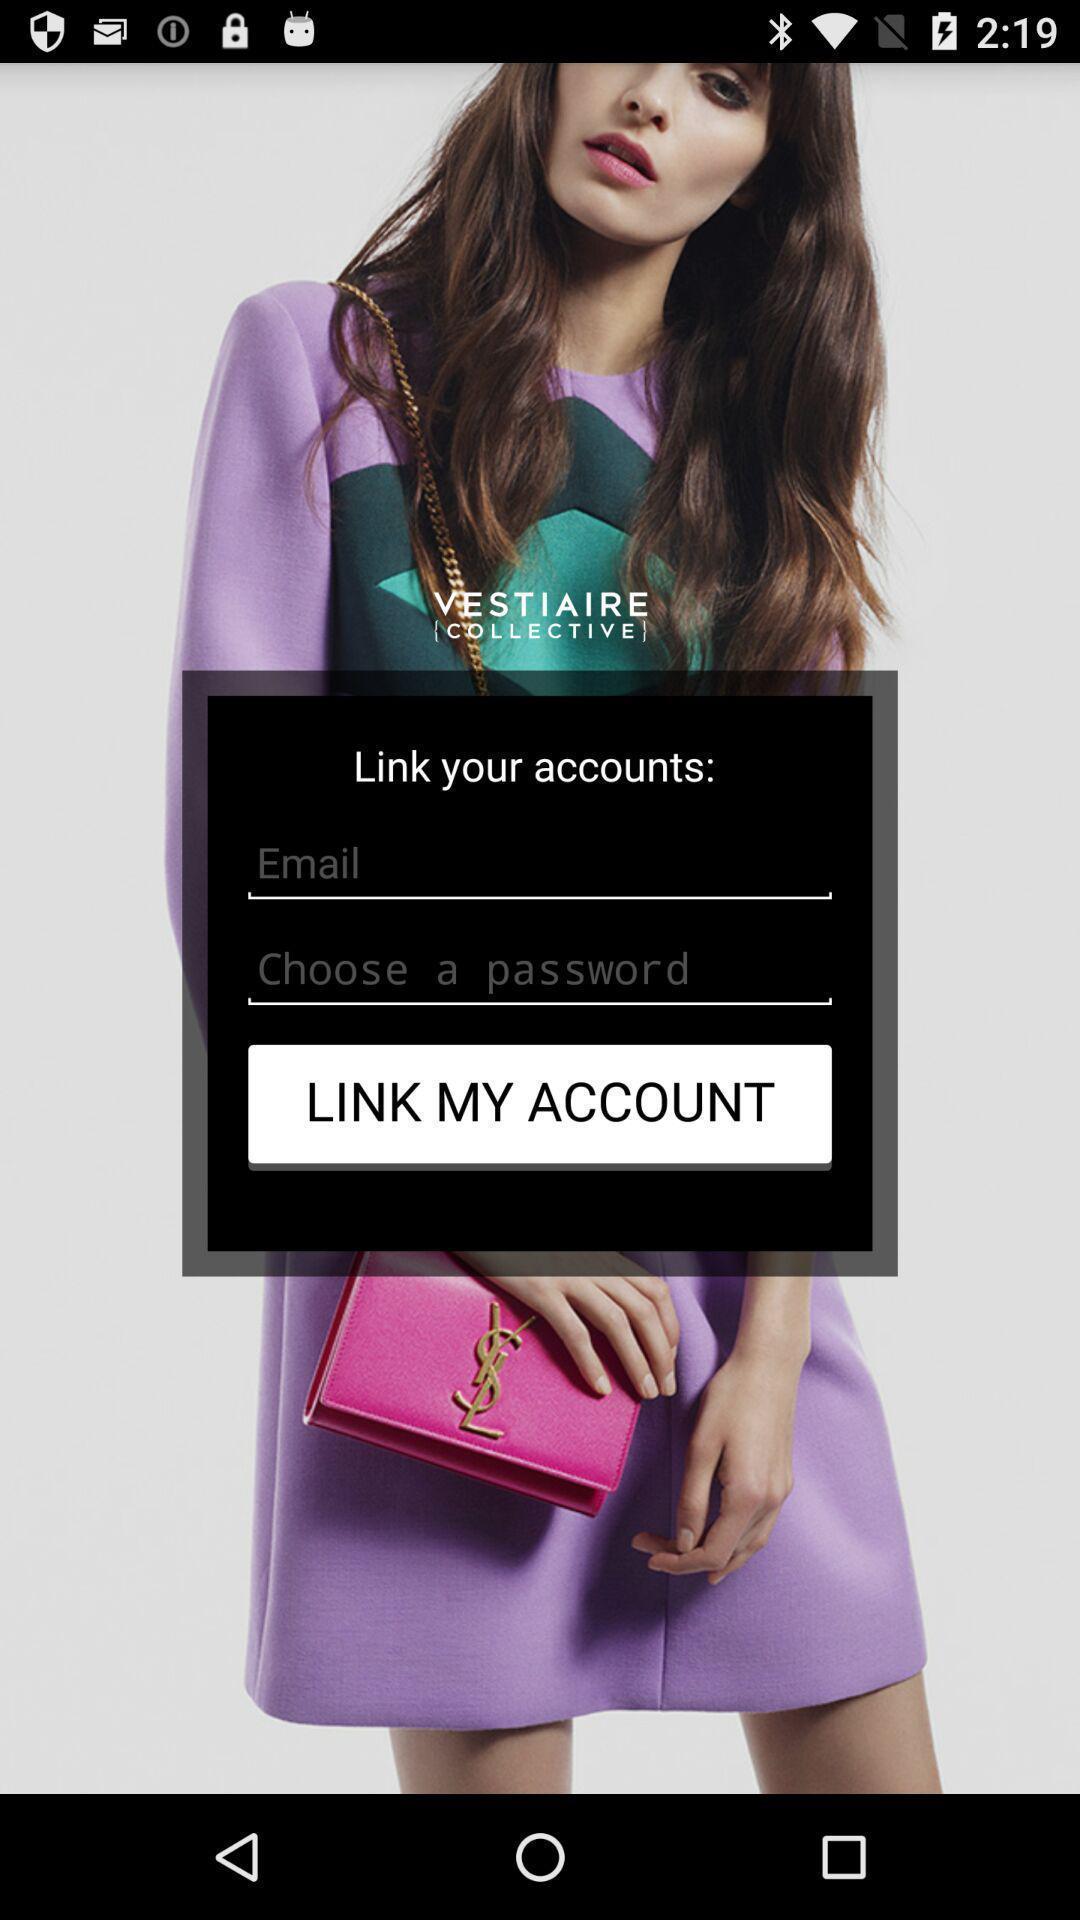Tell me what you see in this picture. Welcome screen with link account option in shopping app. 